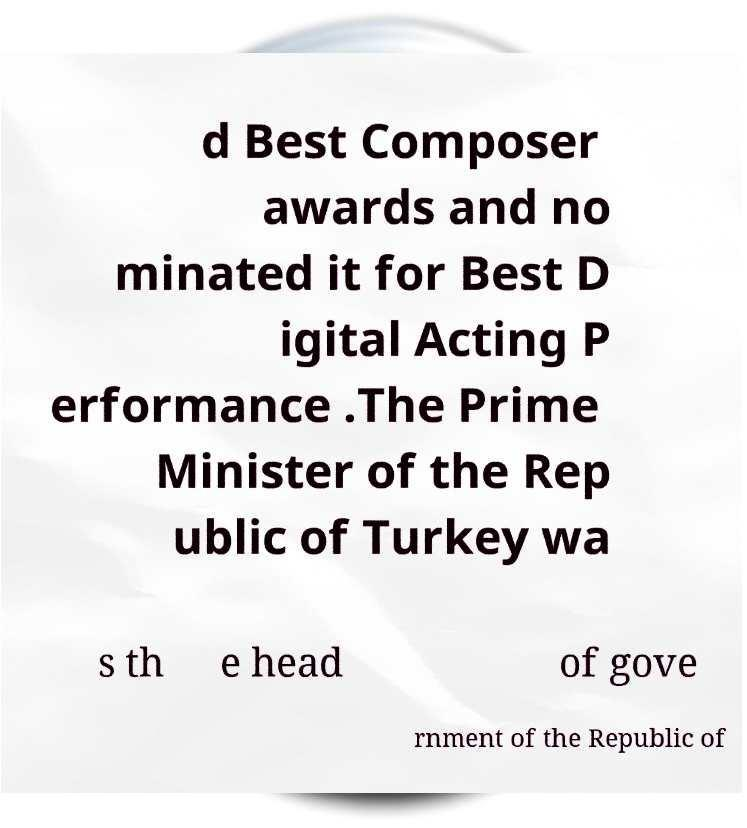Could you assist in decoding the text presented in this image and type it out clearly? d Best Composer awards and no minated it for Best D igital Acting P erformance .The Prime Minister of the Rep ublic of Turkey wa s th e head of gove rnment of the Republic of 